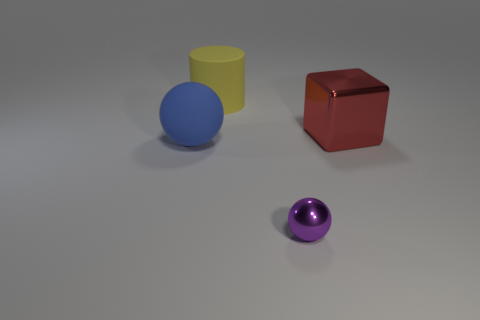Add 1 tiny cyan spheres. How many objects exist? 5 Subtract 1 cubes. How many cubes are left? 0 Subtract all blue balls. How many balls are left? 1 Subtract all blocks. How many objects are left? 3 Subtract all purple spheres. Subtract all brown cylinders. How many spheres are left? 1 Subtract all yellow cylinders. How many blue balls are left? 1 Subtract all small green blocks. Subtract all big blue matte spheres. How many objects are left? 3 Add 3 matte balls. How many matte balls are left? 4 Add 3 big red cubes. How many big red cubes exist? 4 Subtract 1 purple spheres. How many objects are left? 3 